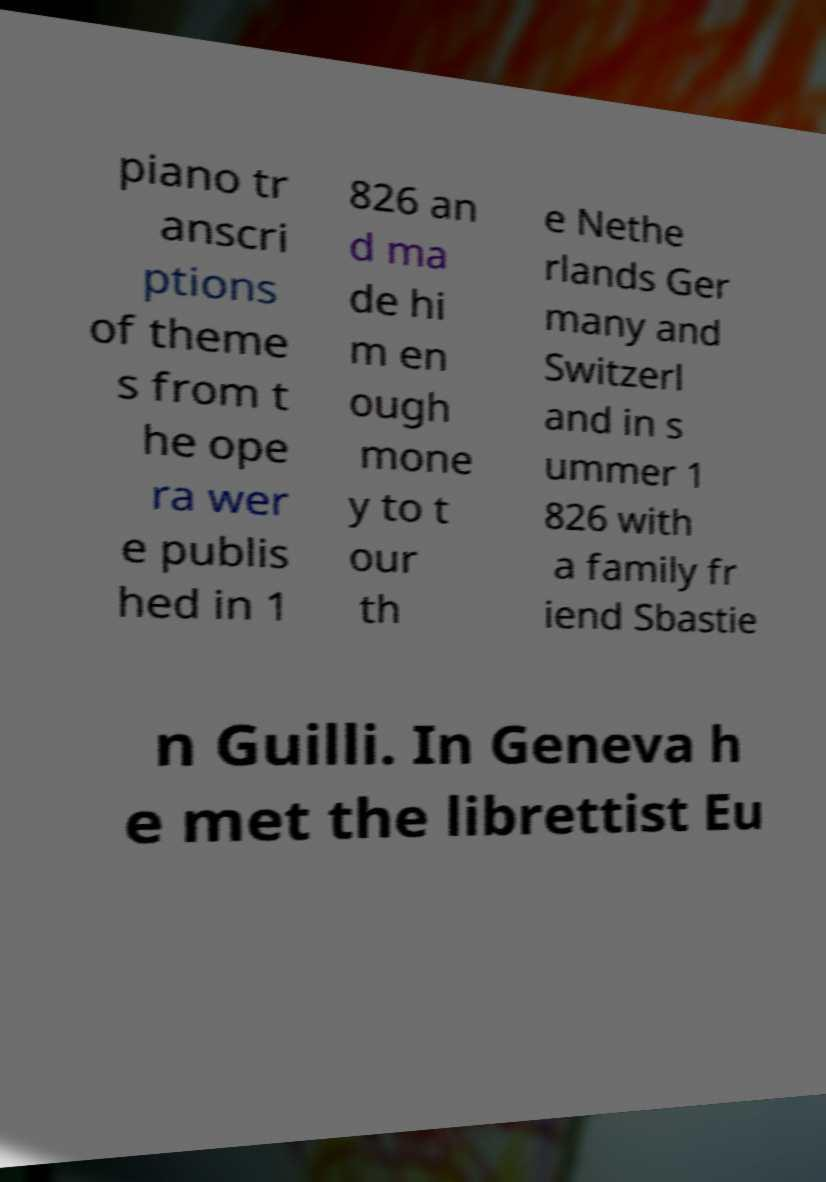For documentation purposes, I need the text within this image transcribed. Could you provide that? piano tr anscri ptions of theme s from t he ope ra wer e publis hed in 1 826 an d ma de hi m en ough mone y to t our th e Nethe rlands Ger many and Switzerl and in s ummer 1 826 with a family fr iend Sbastie n Guilli. In Geneva h e met the librettist Eu 